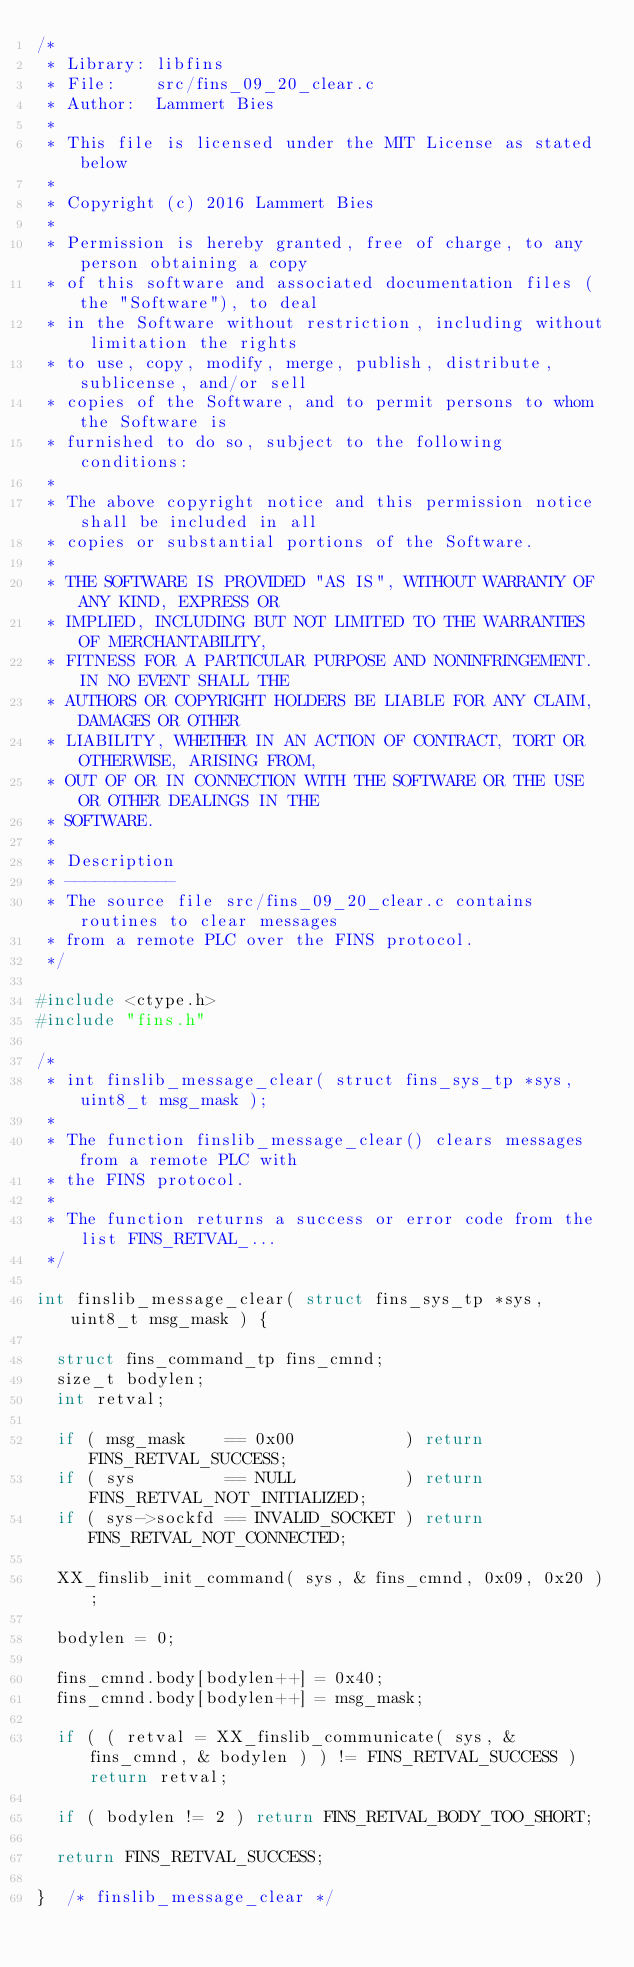<code> <loc_0><loc_0><loc_500><loc_500><_C_>/*
 * Library: libfins
 * File:    src/fins_09_20_clear.c
 * Author:  Lammert Bies
 *
 * This file is licensed under the MIT License as stated below
 *
 * Copyright (c) 2016 Lammert Bies
 *
 * Permission is hereby granted, free of charge, to any person obtaining a copy
 * of this software and associated documentation files (the "Software"), to deal
 * in the Software without restriction, including without limitation the rights
 * to use, copy, modify, merge, publish, distribute, sublicense, and/or sell
 * copies of the Software, and to permit persons to whom the Software is
 * furnished to do so, subject to the following conditions:
 *
 * The above copyright notice and this permission notice shall be included in all
 * copies or substantial portions of the Software.
 *
 * THE SOFTWARE IS PROVIDED "AS IS", WITHOUT WARRANTY OF ANY KIND, EXPRESS OR
 * IMPLIED, INCLUDING BUT NOT LIMITED TO THE WARRANTIES OF MERCHANTABILITY,
 * FITNESS FOR A PARTICULAR PURPOSE AND NONINFRINGEMENT. IN NO EVENT SHALL THE
 * AUTHORS OR COPYRIGHT HOLDERS BE LIABLE FOR ANY CLAIM, DAMAGES OR OTHER
 * LIABILITY, WHETHER IN AN ACTION OF CONTRACT, TORT OR OTHERWISE, ARISING FROM,
 * OUT OF OR IN CONNECTION WITH THE SOFTWARE OR THE USE OR OTHER DEALINGS IN THE
 * SOFTWARE.
 *
 * Description
 * -----------
 * The source file src/fins_09_20_clear.c contains routines to clear messages
 * from a remote PLC over the FINS protocol.
 */

#include <ctype.h>
#include "fins.h"

/*
 * int finslib_message_clear( struct fins_sys_tp *sys, uint8_t msg_mask );
 *
 * The function finslib_message_clear() clears messages from a remote PLC with
 * the FINS protocol.
 *
 * The function returns a success or error code from the list FINS_RETVAL_...
 */

int finslib_message_clear( struct fins_sys_tp *sys, uint8_t msg_mask ) {

	struct fins_command_tp fins_cmnd;
	size_t bodylen;
	int retval;

	if ( msg_mask    == 0x00           ) return FINS_RETVAL_SUCCESS;
	if ( sys         == NULL           ) return FINS_RETVAL_NOT_INITIALIZED;
	if ( sys->sockfd == INVALID_SOCKET ) return FINS_RETVAL_NOT_CONNECTED;

	XX_finslib_init_command( sys, & fins_cmnd, 0x09, 0x20 );

	bodylen = 0;

	fins_cmnd.body[bodylen++] = 0x40;
	fins_cmnd.body[bodylen++] = msg_mask;

	if ( ( retval = XX_finslib_communicate( sys, & fins_cmnd, & bodylen ) ) != FINS_RETVAL_SUCCESS ) return retval;

	if ( bodylen != 2 ) return FINS_RETVAL_BODY_TOO_SHORT;

	return FINS_RETVAL_SUCCESS;

}  /* finslib_message_clear */
</code> 